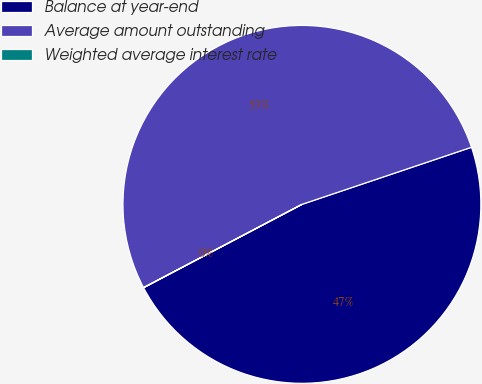<chart> <loc_0><loc_0><loc_500><loc_500><pie_chart><fcel>Balance at year-end<fcel>Average amount outstanding<fcel>Weighted average interest rate<nl><fcel>47.46%<fcel>52.53%<fcel>0.01%<nl></chart> 